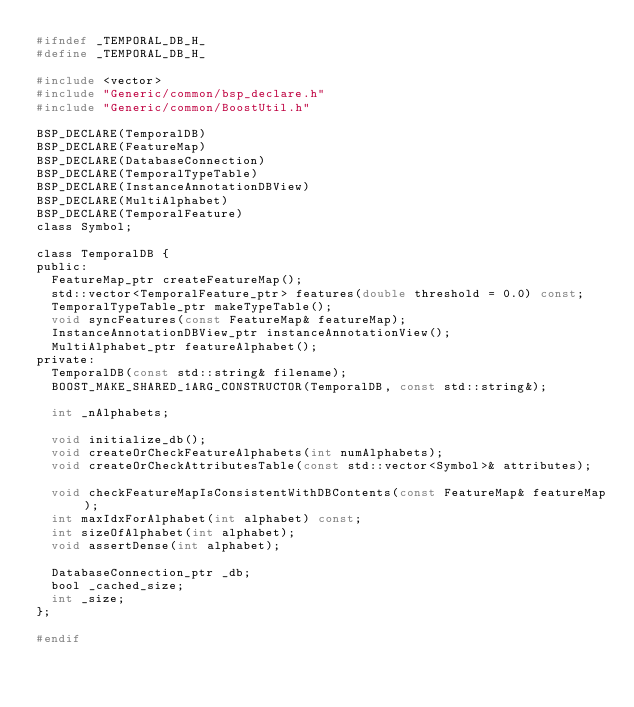Convert code to text. <code><loc_0><loc_0><loc_500><loc_500><_C_>#ifndef _TEMPORAL_DB_H_
#define _TEMPORAL_DB_H_

#include <vector>
#include "Generic/common/bsp_declare.h"
#include "Generic/common/BoostUtil.h"

BSP_DECLARE(TemporalDB)
BSP_DECLARE(FeatureMap)
BSP_DECLARE(DatabaseConnection)
BSP_DECLARE(TemporalTypeTable)
BSP_DECLARE(InstanceAnnotationDBView)
BSP_DECLARE(MultiAlphabet)
BSP_DECLARE(TemporalFeature)
class Symbol;

class TemporalDB {
public:
	FeatureMap_ptr createFeatureMap();
	std::vector<TemporalFeature_ptr> features(double threshold = 0.0) const;
	TemporalTypeTable_ptr makeTypeTable();
	void syncFeatures(const FeatureMap& featureMap);
	InstanceAnnotationDBView_ptr instanceAnnotationView();
	MultiAlphabet_ptr featureAlphabet();
private:
	TemporalDB(const std::string& filename);
	BOOST_MAKE_SHARED_1ARG_CONSTRUCTOR(TemporalDB, const std::string&);

	int _nAlphabets;

	void initialize_db();
	void createOrCheckFeatureAlphabets(int numAlphabets);
	void createOrCheckAttributesTable(const std::vector<Symbol>& attributes);
	
	void checkFeatureMapIsConsistentWithDBContents(const FeatureMap& featureMap);
	int maxIdxForAlphabet(int alphabet) const;
	int sizeOfAlphabet(int alphabet);
	void assertDense(int alphabet);

	DatabaseConnection_ptr _db;
	bool _cached_size;
	int _size;
};

#endif
</code> 